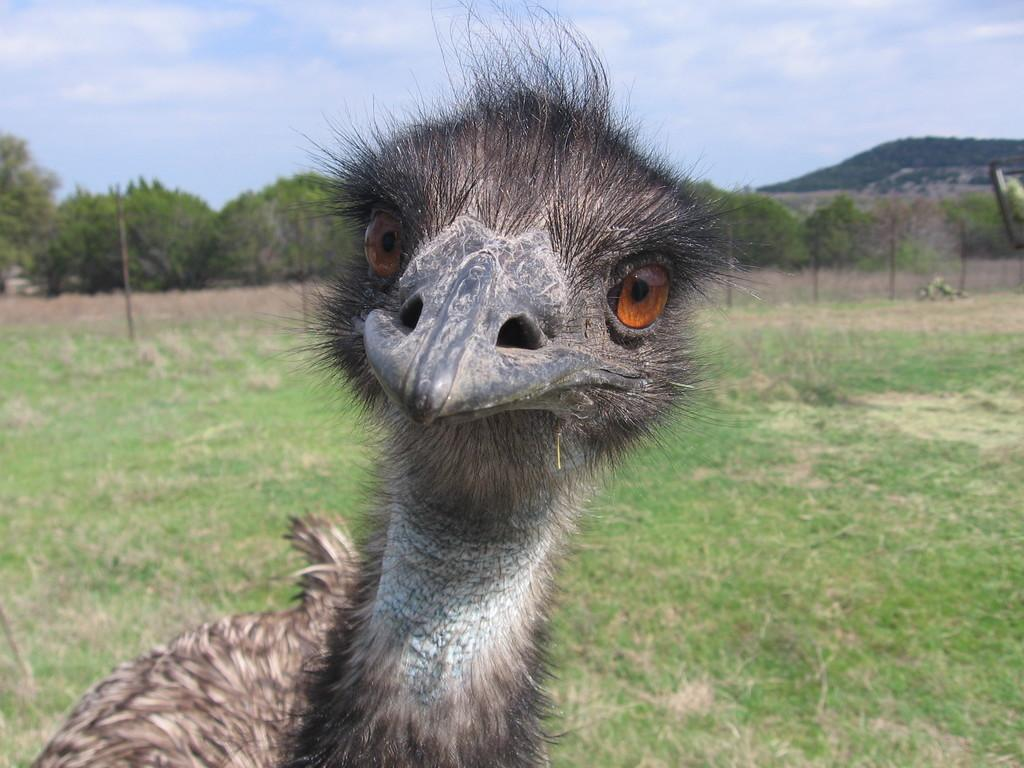What type of animal is in the image? There is a bird in the image. What is the background of the image? There is grassy land behind the bird. What structure can be seen in the image? There is a fence in the image. What other natural elements are present in the image? There are trees in the image. What is visible at the top of the image? The sky is visible at the top of the image. What direction is the bird's friend flying in the image? There is no indication of a friend or any other bird in the image, so it is not possible to determine the direction in which a friend might be flying. 